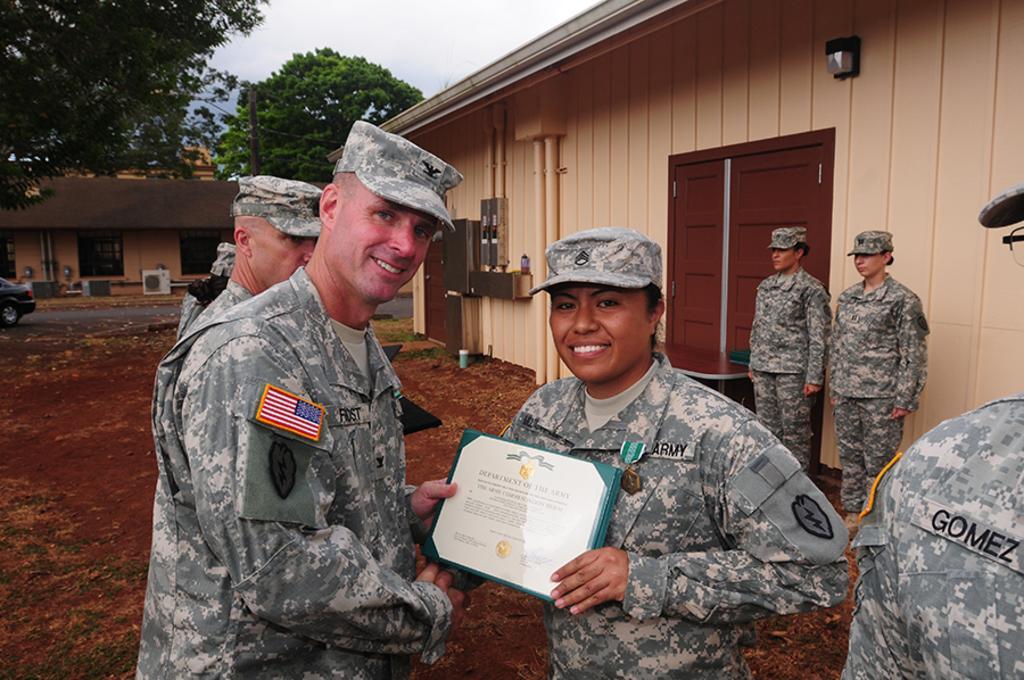Can you describe this image briefly? Here in this picture in the front we can see two person standing on the ground and both of them are wearing military dress and caps on them and smiling and they are holding a certificate in their hands and behind them also we can see other number of people also standing on the ground and beside them we can see a house with windows and doors present and in the left side we can see a car present and behind the house we can see trees present and we can see the sky is cloudy. 